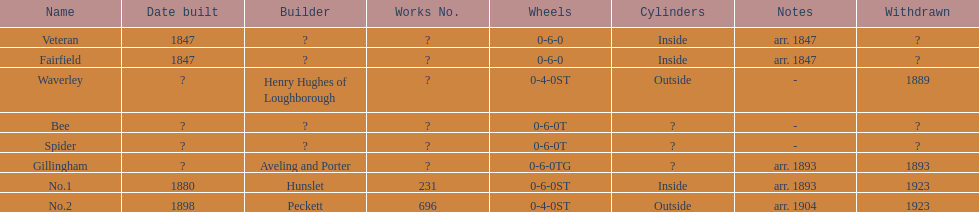How long after fairfield was no. 1 built? 33 years. 